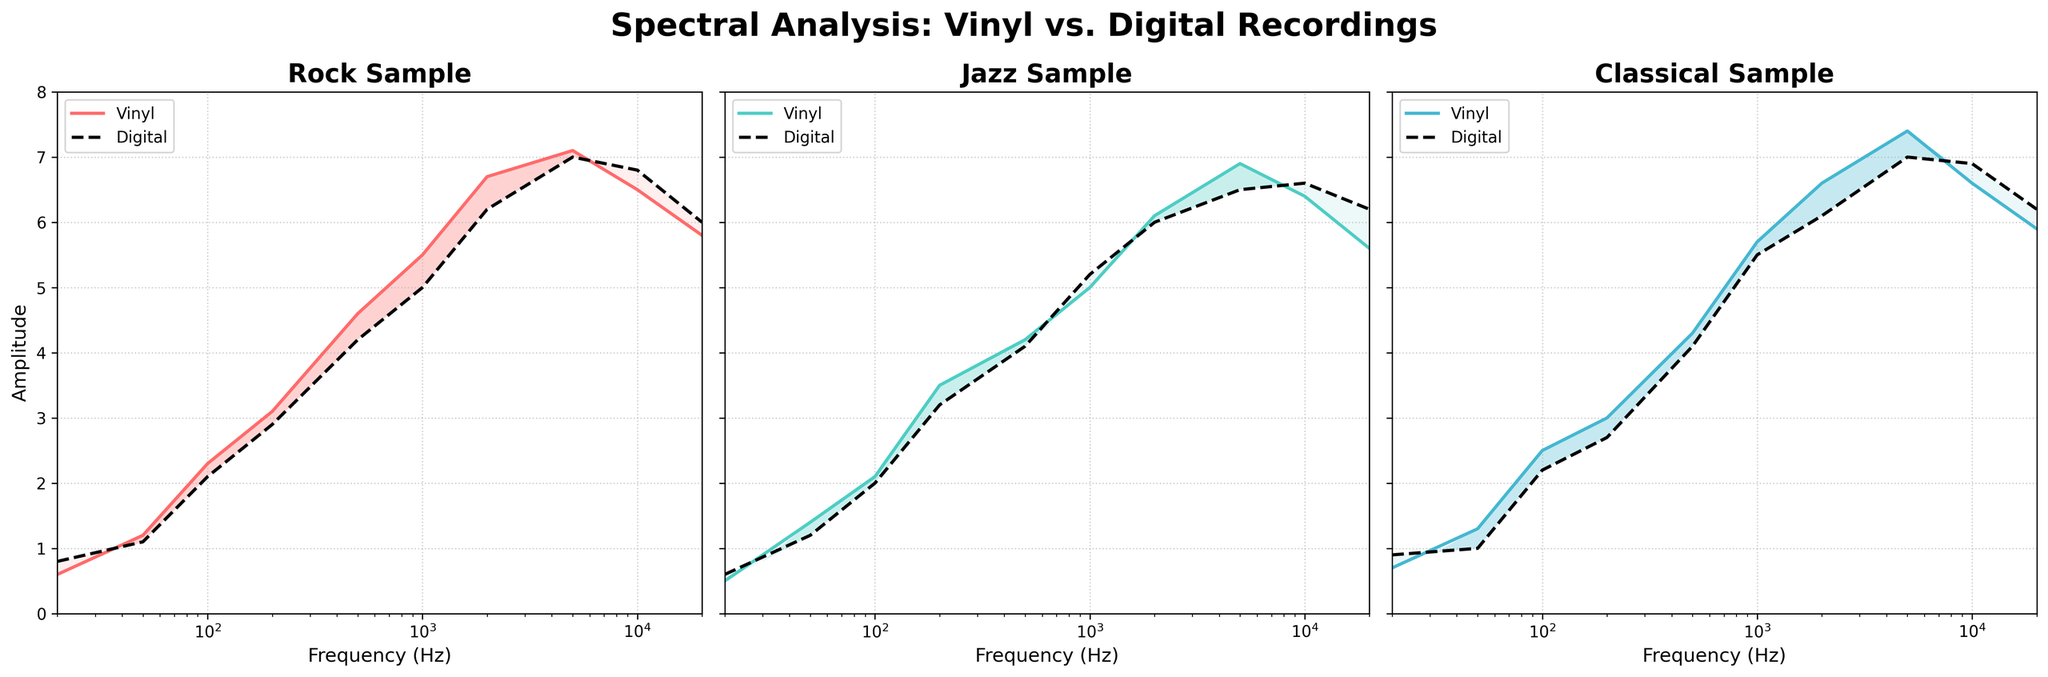What is the overall title of the figure? The title is usually displayed at the top of the figure. It provides a summary of what the figure represents.
Answer: Spectral Analysis: Vinyl vs. Digital Recordings What colors are used to represent Vinyl and Digital recordings in the Classical sample plot? In the Classical sample plot, Vinyl recordings are represented by a specific color and Digital recordings by another. Vinyl recordings are depicted in a color, and Digital in black (dashed line).
Answer: Vinyl: #45B7D1, Digital: black (dashed line) In the Rock sample, at what frequency does Vinyl amplitude first exceed Digital amplitude? By examining the Rock sample plot and comparing the amplitude lines for Vinyl and Digital, one can determine the point where the Vinyl amplitude line rises above the Digital one.
Answer: 20 Hz For the Jazz sample, identify a frequency range where both Vinyl and Digital have the amplitudes similar. By comparing both amplitude lines within the Jazz sample plot, one can visually identify ranges where the lines are closely aligned.
Answer: 5000 Hz to 10000 Hz Which sample shows the highest contour density around 5000 Hz? Contour density is indicated by the closeness of the contour lines. By examining all three sample plots, one can visually identify which sample has the tightest contour lines near 5000 Hz.
Answer: Classical Between Vinyl and Digital recordings in the Classical sample, which has higher amplitude at 20000 Hz? By looking at the amplitude lines at 20000 Hz in the Classical sample plot, it is evident whether the Vinyl or Digital line is higher.
Answer: Digital What is the amplitude difference between Vinyl and Digital at 10000 Hz for the Rock sample? To find this, locate 10000 Hz on the Rock sample plot and note the amplitude values for both Vinyl and Digital. Subtract the smaller value from the larger one.
Answer: 0.3 In the Jazz sample, what is the typical trend of Vinyl amplitude compared to Digital amplitude across the frequency spectrum? By observing the Jazz sample plot, compare the trends of the Vinyl and Digital amplitude lines across various frequencies.
Answer: Vinyl generally has slightly higher amplitude initially but becomes almost equal or lower at higher frequencies Which sample has the greatest amplitude peak for Vinyl recordings? By examining all three sample plots, identify where the Vinyl amplitude reaches its highest point among Rock, Jazz, and Classical.
Answer: Classical (around 5000 Hz) At approximately what frequency do Vinyl and Digital amplitudes cross the first time in the Rock sample? By finding the points of intersection in the Rock sample plot, identify the frequency where the Vinyl line first crosses the Digital line.
Answer: Around 200 Hz 